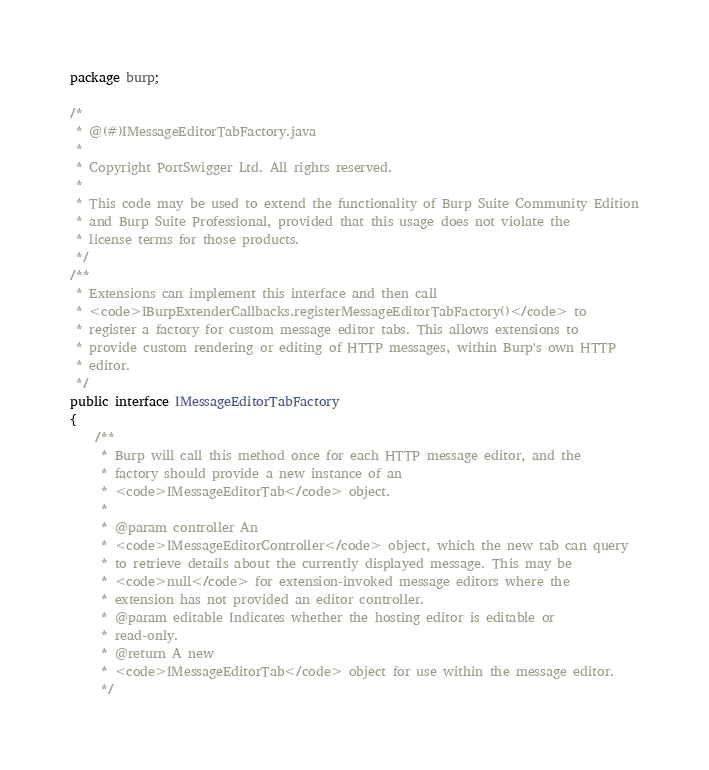<code> <loc_0><loc_0><loc_500><loc_500><_Java_>package burp;

/*
 * @(#)IMessageEditorTabFactory.java
 *
 * Copyright PortSwigger Ltd. All rights reserved.
 *
 * This code may be used to extend the functionality of Burp Suite Community Edition
 * and Burp Suite Professional, provided that this usage does not violate the
 * license terms for those products.
 */
/**
 * Extensions can implement this interface and then call
 * <code>IBurpExtenderCallbacks.registerMessageEditorTabFactory()</code> to
 * register a factory for custom message editor tabs. This allows extensions to
 * provide custom rendering or editing of HTTP messages, within Burp's own HTTP
 * editor.
 */
public interface IMessageEditorTabFactory
{
    /**
     * Burp will call this method once for each HTTP message editor, and the
     * factory should provide a new instance of an
     * <code>IMessageEditorTab</code> object.
     *
     * @param controller An
     * <code>IMessageEditorController</code> object, which the new tab can query
     * to retrieve details about the currently displayed message. This may be
     * <code>null</code> for extension-invoked message editors where the
     * extension has not provided an editor controller.
     * @param editable Indicates whether the hosting editor is editable or
     * read-only.
     * @return A new
     * <code>IMessageEditorTab</code> object for use within the message editor.
     */</code> 